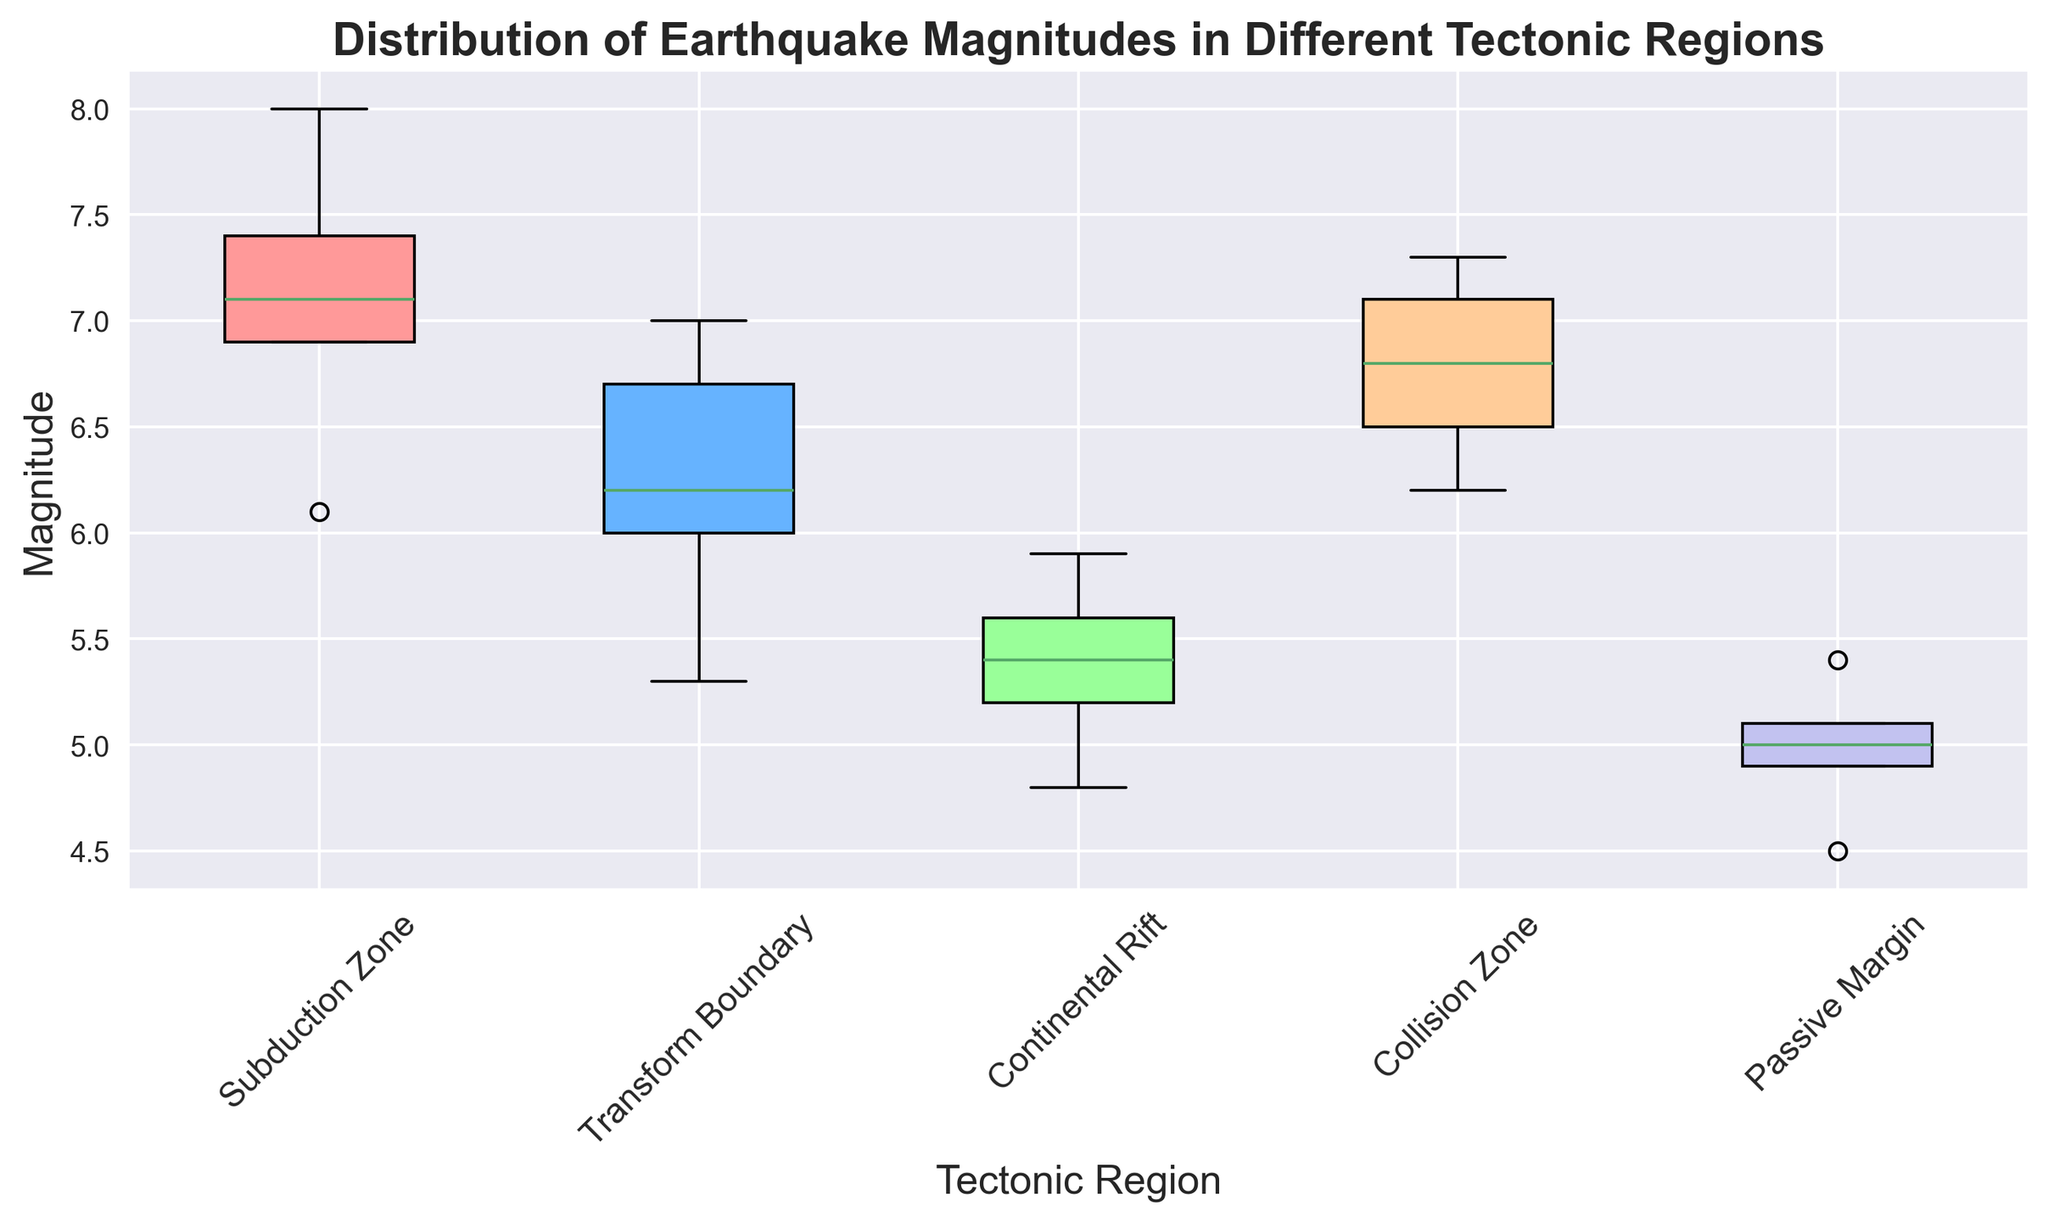Which tectonic region has the highest median earthquake magnitude? To find the region with the highest median earthquake magnitude, look at the central line within each box plot representing the median values. Compare these median lines across different regions.
Answer: Subduction Zone What is the interquartile range (IQR) of earthquake magnitudes for the Continental Rift region? The interquartile range (IQR) is the distance between the first quartile (Q1) and the third quartile (Q3) values in a box plot. Identify Q1 and Q3 in the box plot for the Continental Rift region, then subtract Q1 from Q3.
Answer: 5.9 - 5.2 = 0.7 Which region has the smallest range of earthquake magnitudes? The range of earthquake magnitudes is represented by the length of the whiskers in the box plot. Compare the lengths of the whiskers for each region to determine the smallest range.
Answer: Passive Margin How does the distribution of earthquake magnitudes in the Transform Boundary region compare to the Collision Zone region? To compare the distributions, look at the spread (range), median, and interquartile range (IQR) in both box plots. Note differences in central tendency and variability.
Answer: Transform Boundary has lower magnitudes and less variability Which region appears to have the most variable earthquake magnitudes? The variability of earthquake magnitudes can be seen by the spread of the box plot, including the interquartile range (IQR) and the length of the whiskers. Identify the region with the widest box and longest whiskers.
Answer: Subduction Zone Is the median earthquake magnitude in the Passive Margin region greater than that in the Continental Rift region? Compare the median lines within the boxes of the Passive Margin and Continental Rift regions. Check if the line in the Passive Margin region is higher.
Answer: No What is the difference between the maximum magnitude observed in the Collision Zone and the maximum magnitude observed in the Transform Boundary? Locate the maximum whisker points for both the Collision Zone and the Transform Boundary regions, then subtract the maximum value in the Transform Boundary region from the maximum value in the Collision Zone region.
Answer: 7.3 - 7.0 = 0.3 Which region shows the least central tendency (median value) for earthquake magnitudes? To determine the region with the least central tendency, identify the region with the lowest median line within the box.
Answer: Passive Margin 